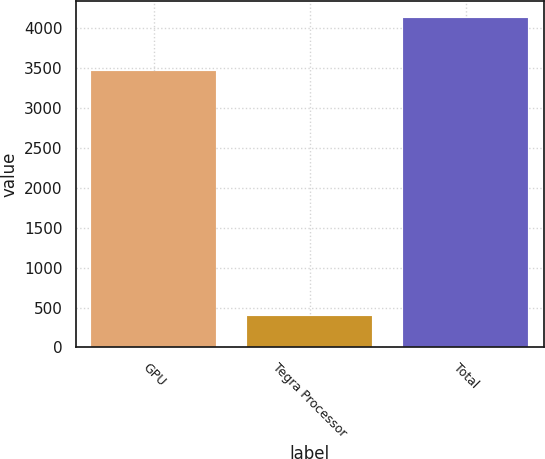Convert chart to OTSL. <chart><loc_0><loc_0><loc_500><loc_500><bar_chart><fcel>GPU<fcel>Tegra Processor<fcel>Total<nl><fcel>3468<fcel>398<fcel>4130<nl></chart> 